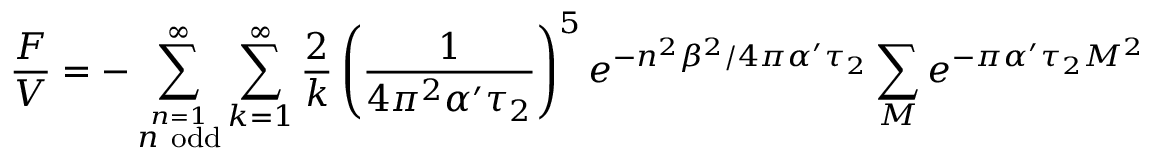Convert formula to latex. <formula><loc_0><loc_0><loc_500><loc_500>\frac { F } { V } = - \sum _ { \stackrel { n = 1 } { n o d d } } ^ { \infty } \sum _ { k = 1 } ^ { \infty } \frac { 2 } { k } \left ( \frac { 1 } { 4 \pi ^ { 2 } \alpha ^ { \prime } \tau _ { 2 } } \right ) ^ { 5 } e ^ { - n ^ { 2 } \beta ^ { 2 } / 4 \pi \alpha ^ { \prime } \tau _ { 2 } } \sum _ { M } e ^ { - \pi \alpha ^ { \prime } \tau _ { 2 } M ^ { 2 } }</formula> 